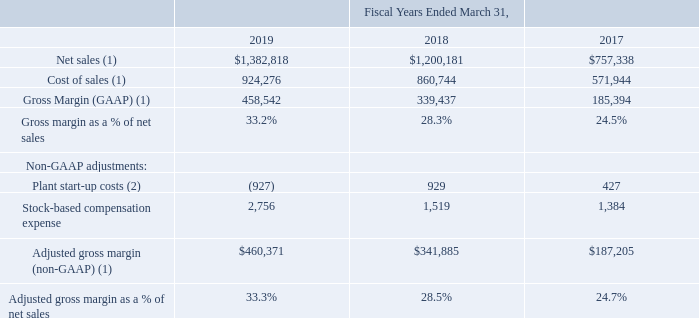Non-GAAP Financial Measures
To complement our Consolidated Statements of Operations and Cash Flows, we use non-GAAP financial measures of Adjusted gross margin, Adjusted operating income, Adjusted net income, and Adjusted EBITDA. We believe that Adjusted gross margin, Adjusted operating income, Adjusted net income, and Adjusted EBITDA are complements to U.S. GAAP amounts and such measures are useful to investors. The presentation of these non-GAAP measures is not meant to be considered in isolation or as an alternative to net income as an indicator of our performance, or as an alternative to cash flows from operating activities as a measure of liquidity.
The following table provides a reconciliation from U.S. GAAP Gross margin to non-GAAP Adjusted gross margin (amounts in thousands):
(1) Fiscal years ending March 31, 2018 and 2017 adjusted due to the adoption of ASC 606.
(2) $0.9 million in costs incurred during fiscal year 2018 related to the relocation of the Company's tantalum powder facility equipment from Carson City, Nevada to its existing Matamoros, Mexico plant were reclassified from “Plant start-up costs” to “Restructuring charges” during fiscal year 2019.
Which years does the table provide information for the  reconciliation from U.S. GAAP Gross margin to non-GAAP Adjusted gross margin? 2019, 2018, 2017. What were the net sales in 2018?
Answer scale should be: thousand. 1,200,181. What was the gross margin (GAAP) in 2017?
Answer scale should be: thousand. 185,394. What was the change in net sales between 2017 and 2019?
Answer scale should be: thousand. 1,382,818-757,338
Answer: 625480. How many years did cost of sales exceed $800,000 thousand? 2019##2018
Answer: 2. What was the percentage change in Stock-based compensation expense between 2018 and 2019?
Answer scale should be: percent. (2,756-1,519)/1,519
Answer: 81.44. 